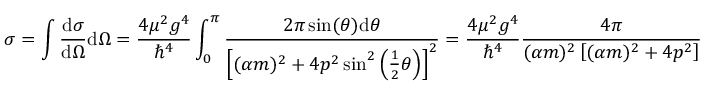Convert formula to latex. <formula><loc_0><loc_0><loc_500><loc_500>\sigma = \int { \frac { d \sigma } { d \Omega } } d \Omega = { \frac { 4 \mu ^ { 2 } g ^ { 4 } } { \hbar { ^ } { 4 } } } \int _ { 0 } ^ { \pi } { \frac { 2 \pi \sin ( \theta ) d \theta } { \left [ ( \alpha m ) ^ { 2 } + 4 p ^ { 2 } \sin ^ { 2 } \left ( { \frac { 1 } { 2 } } \theta \right ) \right ] ^ { 2 } } } = { \frac { 4 \mu ^ { 2 } g ^ { 4 } } { \hbar { ^ } { 4 } } } { \frac { 4 \pi } { ( \alpha m ) ^ { 2 } \left [ ( \alpha m ) ^ { 2 } + 4 p ^ { 2 } \right ] } }</formula> 